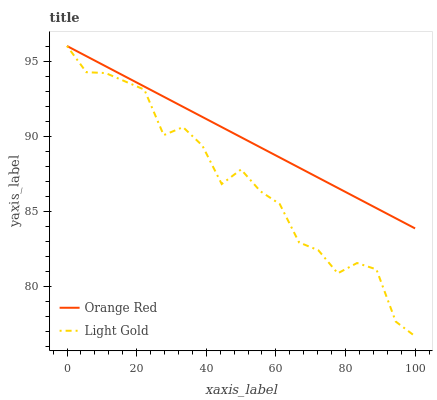Does Light Gold have the minimum area under the curve?
Answer yes or no. Yes. Does Orange Red have the maximum area under the curve?
Answer yes or no. Yes. Does Orange Red have the minimum area under the curve?
Answer yes or no. No. Is Orange Red the smoothest?
Answer yes or no. Yes. Is Light Gold the roughest?
Answer yes or no. Yes. Is Orange Red the roughest?
Answer yes or no. No. Does Orange Red have the lowest value?
Answer yes or no. No. Does Orange Red have the highest value?
Answer yes or no. Yes. Does Light Gold intersect Orange Red?
Answer yes or no. Yes. Is Light Gold less than Orange Red?
Answer yes or no. No. Is Light Gold greater than Orange Red?
Answer yes or no. No. 